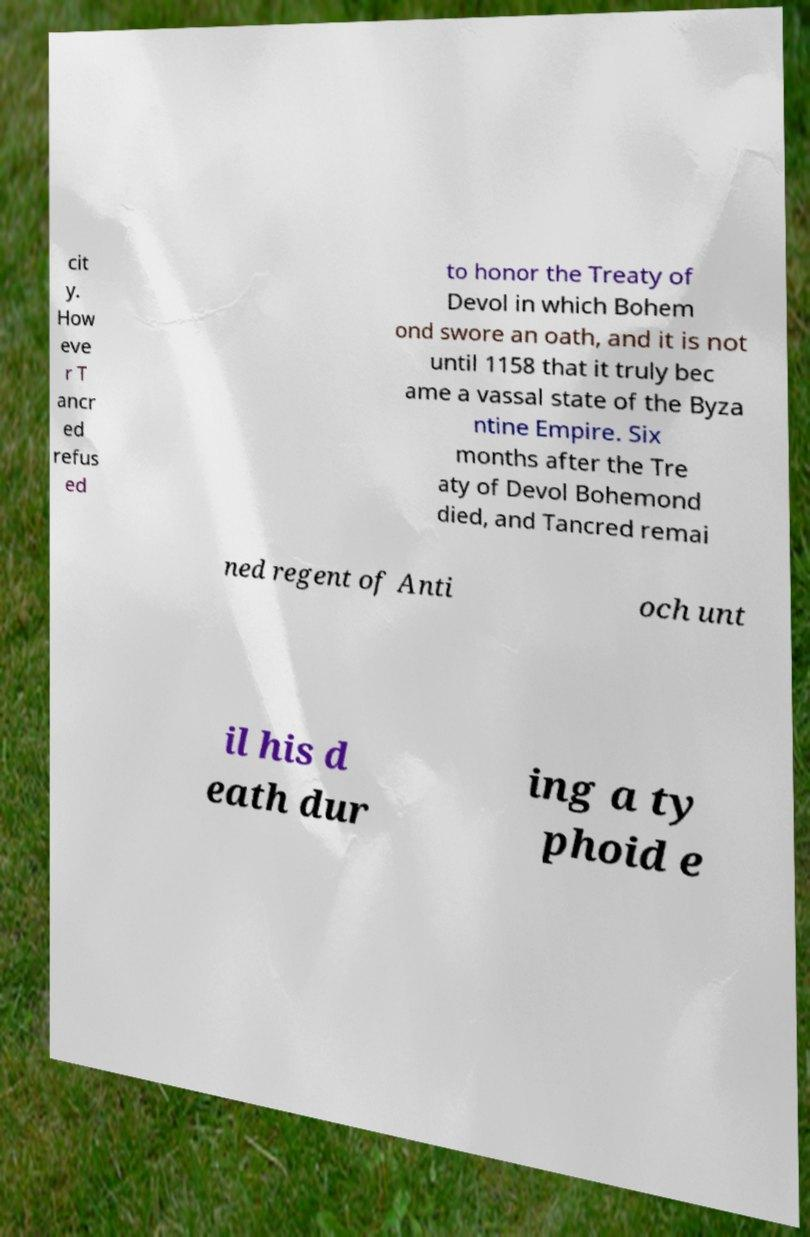Can you accurately transcribe the text from the provided image for me? cit y. How eve r T ancr ed refus ed to honor the Treaty of Devol in which Bohem ond swore an oath, and it is not until 1158 that it truly bec ame a vassal state of the Byza ntine Empire. Six months after the Tre aty of Devol Bohemond died, and Tancred remai ned regent of Anti och unt il his d eath dur ing a ty phoid e 